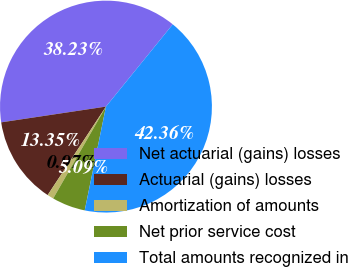<chart> <loc_0><loc_0><loc_500><loc_500><pie_chart><fcel>Net actuarial (gains) losses<fcel>Actuarial (gains) losses<fcel>Amortization of amounts<fcel>Net prior service cost<fcel>Total amounts recognized in<nl><fcel>38.23%<fcel>13.35%<fcel>0.97%<fcel>5.09%<fcel>42.36%<nl></chart> 